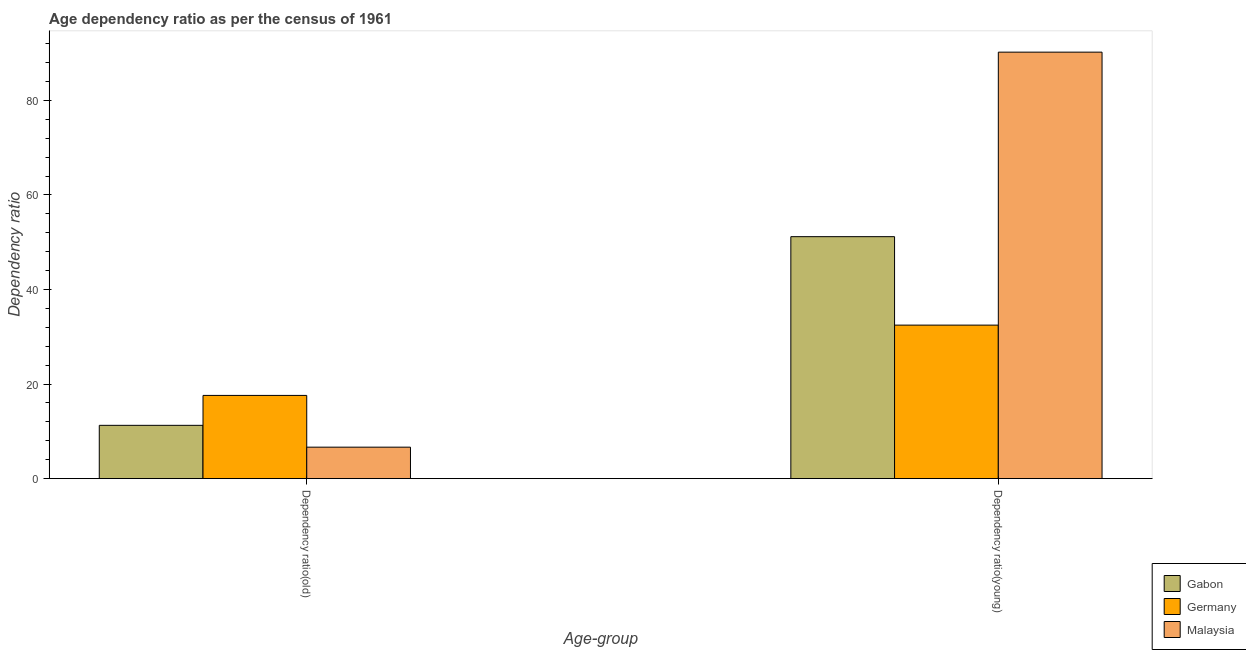How many bars are there on the 2nd tick from the right?
Provide a short and direct response. 3. What is the label of the 1st group of bars from the left?
Offer a very short reply. Dependency ratio(old). What is the age dependency ratio(young) in Germany?
Give a very brief answer. 32.47. Across all countries, what is the maximum age dependency ratio(young)?
Your response must be concise. 90.2. Across all countries, what is the minimum age dependency ratio(young)?
Keep it short and to the point. 32.47. In which country was the age dependency ratio(old) minimum?
Offer a terse response. Malaysia. What is the total age dependency ratio(old) in the graph?
Provide a succinct answer. 35.51. What is the difference between the age dependency ratio(old) in Malaysia and that in Germany?
Give a very brief answer. -10.94. What is the difference between the age dependency ratio(young) in Germany and the age dependency ratio(old) in Malaysia?
Your answer should be compact. 25.81. What is the average age dependency ratio(young) per country?
Give a very brief answer. 57.94. What is the difference between the age dependency ratio(old) and age dependency ratio(young) in Malaysia?
Your answer should be compact. -83.55. In how many countries, is the age dependency ratio(young) greater than 64 ?
Provide a short and direct response. 1. What is the ratio of the age dependency ratio(young) in Germany to that in Malaysia?
Offer a terse response. 0.36. Is the age dependency ratio(old) in Malaysia less than that in Germany?
Keep it short and to the point. Yes. In how many countries, is the age dependency ratio(old) greater than the average age dependency ratio(old) taken over all countries?
Ensure brevity in your answer.  1. What does the 1st bar from the left in Dependency ratio(young) represents?
Offer a very short reply. Gabon. What does the 3rd bar from the right in Dependency ratio(old) represents?
Provide a short and direct response. Gabon. How many bars are there?
Your answer should be compact. 6. Are all the bars in the graph horizontal?
Provide a succinct answer. No. Are the values on the major ticks of Y-axis written in scientific E-notation?
Keep it short and to the point. No. Does the graph contain any zero values?
Your response must be concise. No. Does the graph contain grids?
Ensure brevity in your answer.  No. Where does the legend appear in the graph?
Give a very brief answer. Bottom right. How many legend labels are there?
Offer a terse response. 3. How are the legend labels stacked?
Your answer should be compact. Vertical. What is the title of the graph?
Offer a very short reply. Age dependency ratio as per the census of 1961. Does "Lithuania" appear as one of the legend labels in the graph?
Your answer should be compact. No. What is the label or title of the X-axis?
Offer a terse response. Age-group. What is the label or title of the Y-axis?
Provide a succinct answer. Dependency ratio. What is the Dependency ratio in Gabon in Dependency ratio(old)?
Make the answer very short. 11.27. What is the Dependency ratio of Germany in Dependency ratio(old)?
Make the answer very short. 17.59. What is the Dependency ratio in Malaysia in Dependency ratio(old)?
Provide a short and direct response. 6.65. What is the Dependency ratio in Gabon in Dependency ratio(young)?
Your response must be concise. 51.17. What is the Dependency ratio in Germany in Dependency ratio(young)?
Offer a very short reply. 32.47. What is the Dependency ratio of Malaysia in Dependency ratio(young)?
Provide a succinct answer. 90.2. Across all Age-group, what is the maximum Dependency ratio of Gabon?
Provide a succinct answer. 51.17. Across all Age-group, what is the maximum Dependency ratio in Germany?
Your answer should be very brief. 32.47. Across all Age-group, what is the maximum Dependency ratio in Malaysia?
Make the answer very short. 90.2. Across all Age-group, what is the minimum Dependency ratio in Gabon?
Your answer should be very brief. 11.27. Across all Age-group, what is the minimum Dependency ratio in Germany?
Your response must be concise. 17.59. Across all Age-group, what is the minimum Dependency ratio of Malaysia?
Your answer should be very brief. 6.65. What is the total Dependency ratio of Gabon in the graph?
Make the answer very short. 62.44. What is the total Dependency ratio of Germany in the graph?
Your response must be concise. 50.06. What is the total Dependency ratio in Malaysia in the graph?
Offer a terse response. 96.85. What is the difference between the Dependency ratio of Gabon in Dependency ratio(old) and that in Dependency ratio(young)?
Give a very brief answer. -39.9. What is the difference between the Dependency ratio in Germany in Dependency ratio(old) and that in Dependency ratio(young)?
Ensure brevity in your answer.  -14.87. What is the difference between the Dependency ratio of Malaysia in Dependency ratio(old) and that in Dependency ratio(young)?
Offer a terse response. -83.55. What is the difference between the Dependency ratio of Gabon in Dependency ratio(old) and the Dependency ratio of Germany in Dependency ratio(young)?
Keep it short and to the point. -21.2. What is the difference between the Dependency ratio in Gabon in Dependency ratio(old) and the Dependency ratio in Malaysia in Dependency ratio(young)?
Provide a succinct answer. -78.93. What is the difference between the Dependency ratio in Germany in Dependency ratio(old) and the Dependency ratio in Malaysia in Dependency ratio(young)?
Give a very brief answer. -72.6. What is the average Dependency ratio in Gabon per Age-group?
Ensure brevity in your answer.  31.22. What is the average Dependency ratio in Germany per Age-group?
Provide a short and direct response. 25.03. What is the average Dependency ratio of Malaysia per Age-group?
Provide a short and direct response. 48.42. What is the difference between the Dependency ratio in Gabon and Dependency ratio in Germany in Dependency ratio(old)?
Your answer should be very brief. -6.33. What is the difference between the Dependency ratio of Gabon and Dependency ratio of Malaysia in Dependency ratio(old)?
Provide a succinct answer. 4.62. What is the difference between the Dependency ratio in Germany and Dependency ratio in Malaysia in Dependency ratio(old)?
Provide a succinct answer. 10.94. What is the difference between the Dependency ratio of Gabon and Dependency ratio of Germany in Dependency ratio(young)?
Keep it short and to the point. 18.71. What is the difference between the Dependency ratio of Gabon and Dependency ratio of Malaysia in Dependency ratio(young)?
Make the answer very short. -39.02. What is the difference between the Dependency ratio of Germany and Dependency ratio of Malaysia in Dependency ratio(young)?
Your response must be concise. -57.73. What is the ratio of the Dependency ratio of Gabon in Dependency ratio(old) to that in Dependency ratio(young)?
Offer a terse response. 0.22. What is the ratio of the Dependency ratio of Germany in Dependency ratio(old) to that in Dependency ratio(young)?
Keep it short and to the point. 0.54. What is the ratio of the Dependency ratio in Malaysia in Dependency ratio(old) to that in Dependency ratio(young)?
Offer a very short reply. 0.07. What is the difference between the highest and the second highest Dependency ratio in Gabon?
Give a very brief answer. 39.9. What is the difference between the highest and the second highest Dependency ratio in Germany?
Ensure brevity in your answer.  14.87. What is the difference between the highest and the second highest Dependency ratio of Malaysia?
Offer a very short reply. 83.55. What is the difference between the highest and the lowest Dependency ratio of Gabon?
Ensure brevity in your answer.  39.9. What is the difference between the highest and the lowest Dependency ratio in Germany?
Provide a succinct answer. 14.87. What is the difference between the highest and the lowest Dependency ratio of Malaysia?
Your answer should be compact. 83.55. 